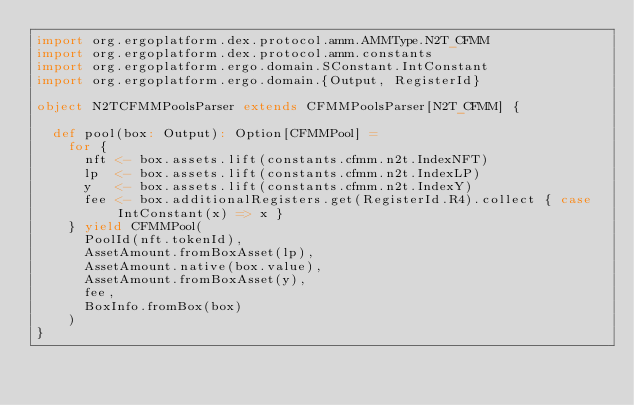Convert code to text. <code><loc_0><loc_0><loc_500><loc_500><_Scala_>import org.ergoplatform.dex.protocol.amm.AMMType.N2T_CFMM
import org.ergoplatform.dex.protocol.amm.constants
import org.ergoplatform.ergo.domain.SConstant.IntConstant
import org.ergoplatform.ergo.domain.{Output, RegisterId}

object N2TCFMMPoolsParser extends CFMMPoolsParser[N2T_CFMM] {

  def pool(box: Output): Option[CFMMPool] =
    for {
      nft <- box.assets.lift(constants.cfmm.n2t.IndexNFT)
      lp  <- box.assets.lift(constants.cfmm.n2t.IndexLP)
      y   <- box.assets.lift(constants.cfmm.n2t.IndexY)
      fee <- box.additionalRegisters.get(RegisterId.R4).collect { case IntConstant(x) => x }
    } yield CFMMPool(
      PoolId(nft.tokenId),
      AssetAmount.fromBoxAsset(lp),
      AssetAmount.native(box.value),
      AssetAmount.fromBoxAsset(y),
      fee,
      BoxInfo.fromBox(box)
    )
}
</code> 